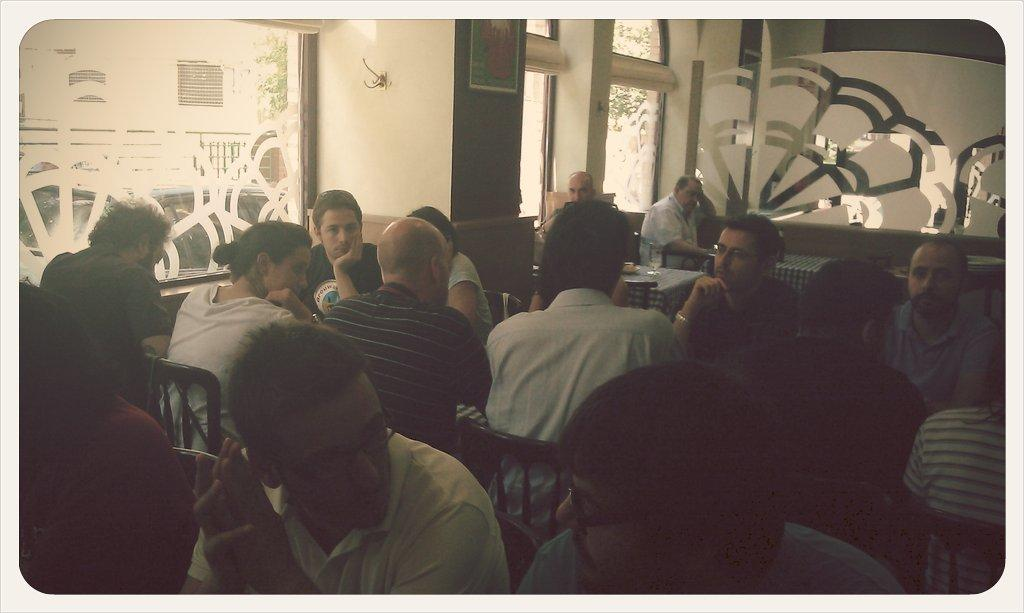What are the people in the image doing? The people in the image are sitting on chairs. Where does the scene take place? The scene takes place in a room. What can be seen on the left side of the room? There are glass windows on the left side of the room. What is hanging on the wall in the room? There is a photo frame on the wall in the room. What type of thread is being used to play volleyball in the image? There is no volleyball or thread present in the image; the people are sitting on chairs in a room with glass windows and a photo frame on the wall. 